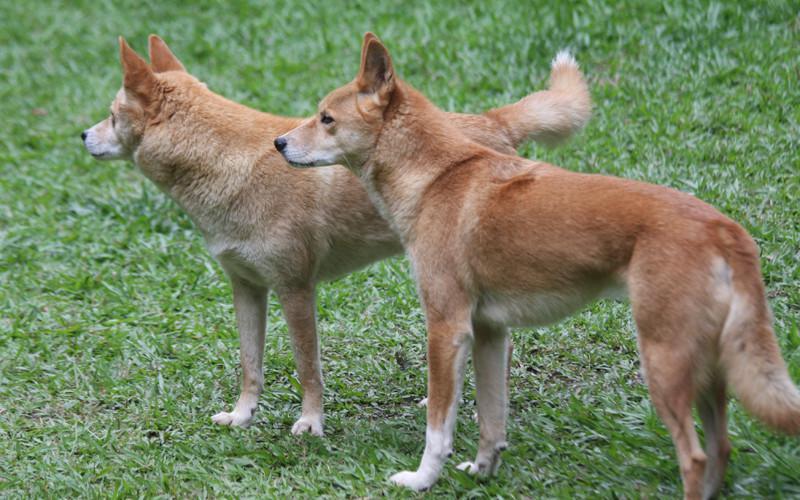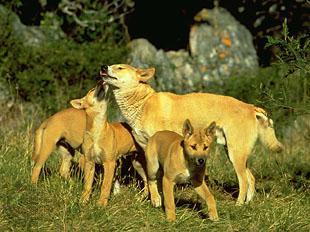The first image is the image on the left, the second image is the image on the right. Evaluate the accuracy of this statement regarding the images: "All golden colored dogs are standing up in the grass (not laying down.)". Is it true? Answer yes or no. Yes. The first image is the image on the left, the second image is the image on the right. Assess this claim about the two images: "One image contains a reclining dingo and the other contains a dingo that is walking with body in profile.". Correct or not? Answer yes or no. No. 